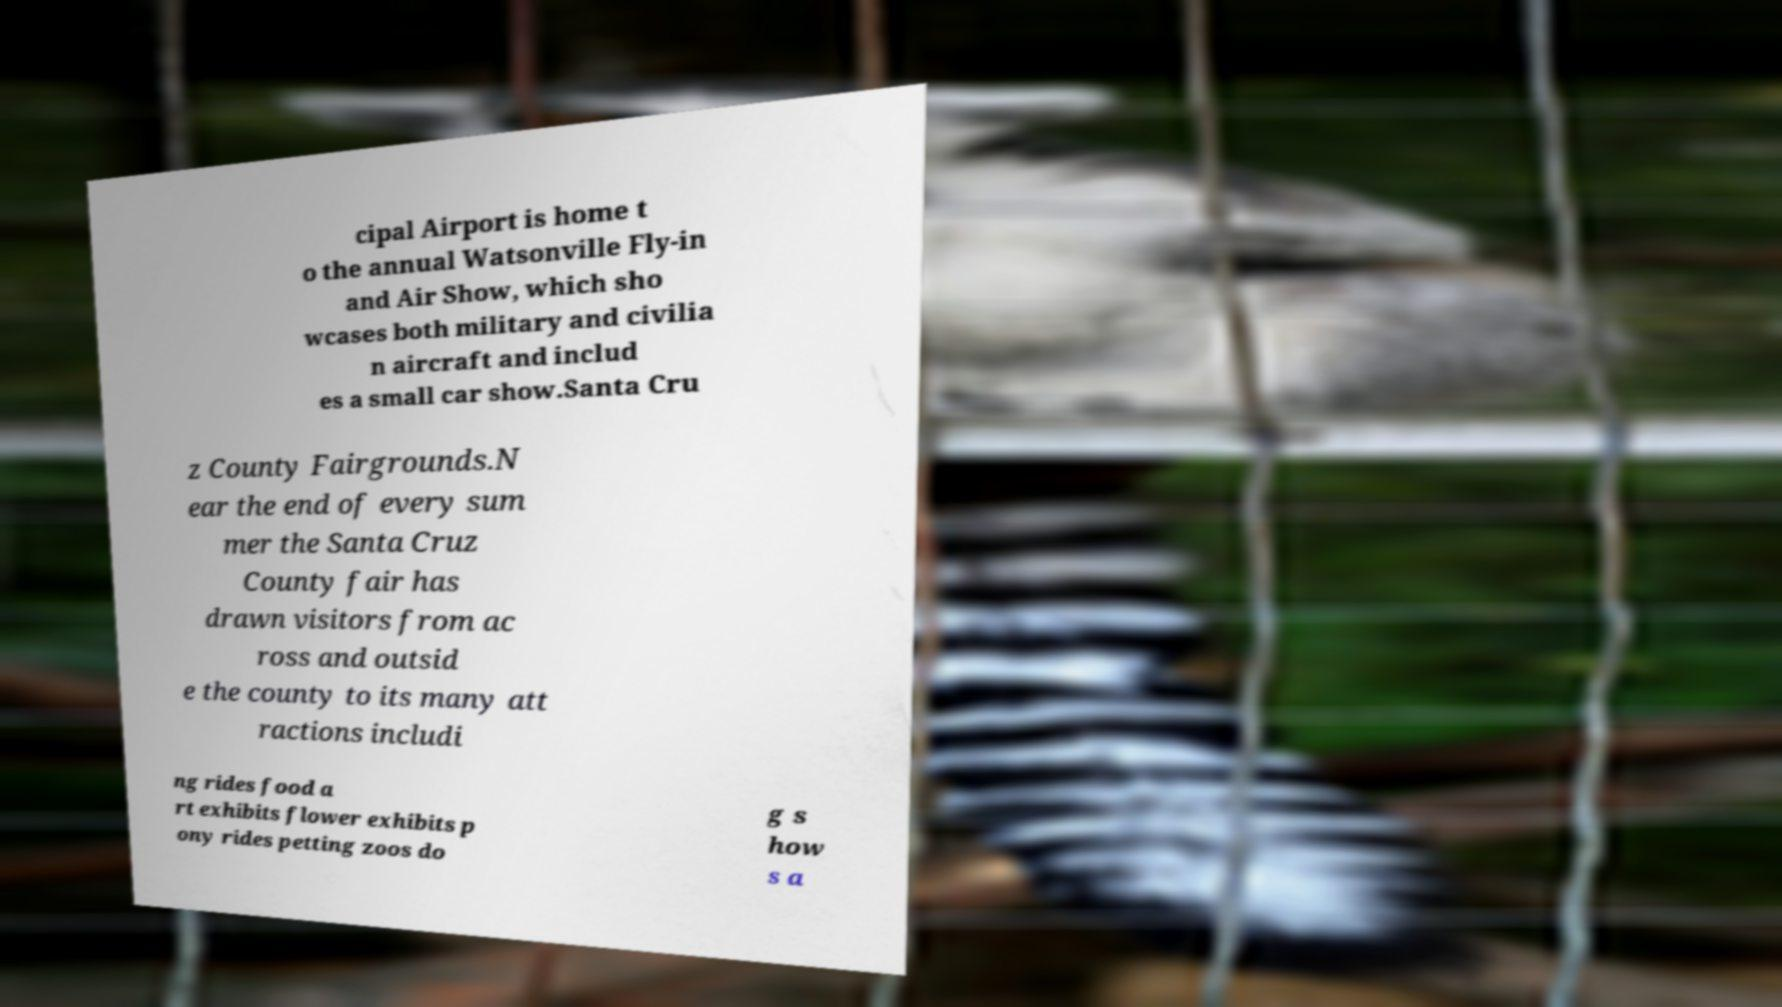Could you assist in decoding the text presented in this image and type it out clearly? cipal Airport is home t o the annual Watsonville Fly-in and Air Show, which sho wcases both military and civilia n aircraft and includ es a small car show.Santa Cru z County Fairgrounds.N ear the end of every sum mer the Santa Cruz County fair has drawn visitors from ac ross and outsid e the county to its many att ractions includi ng rides food a rt exhibits flower exhibits p ony rides petting zoos do g s how s a 